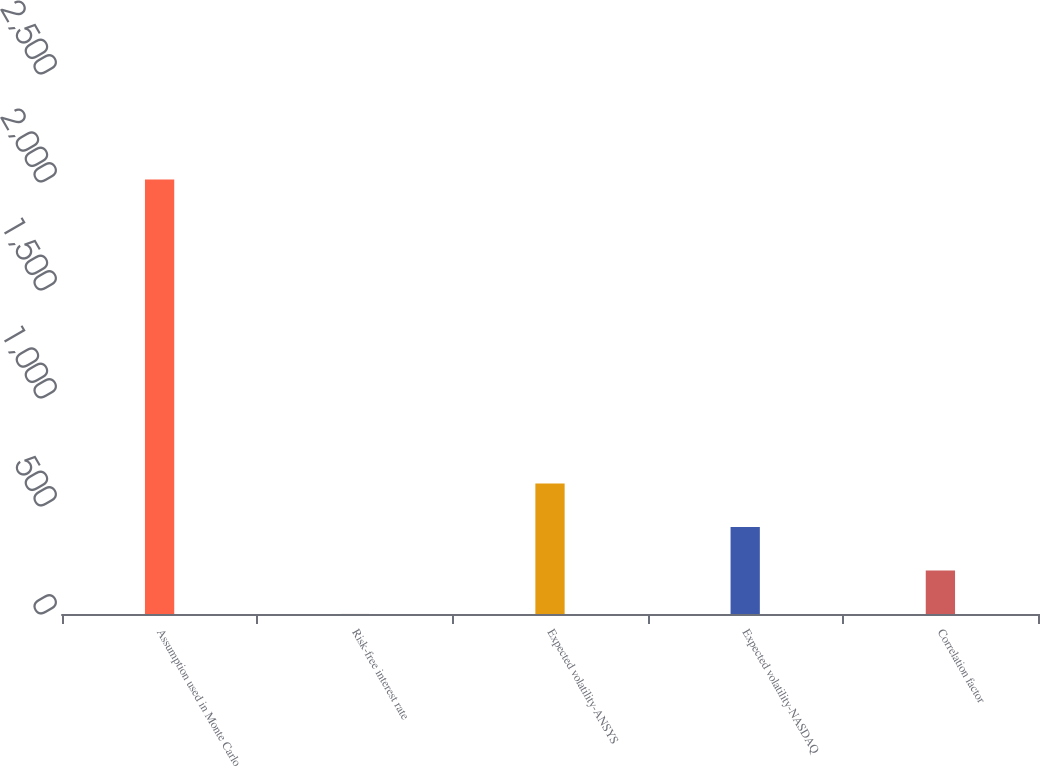<chart> <loc_0><loc_0><loc_500><loc_500><bar_chart><fcel>Assumption used in Monte Carlo<fcel>Risk-free interest rate<fcel>Expected volatility-ANSYS<fcel>Expected volatility-NASDAQ<fcel>Correlation factor<nl><fcel>2012<fcel>0.16<fcel>603.7<fcel>402.52<fcel>201.34<nl></chart> 